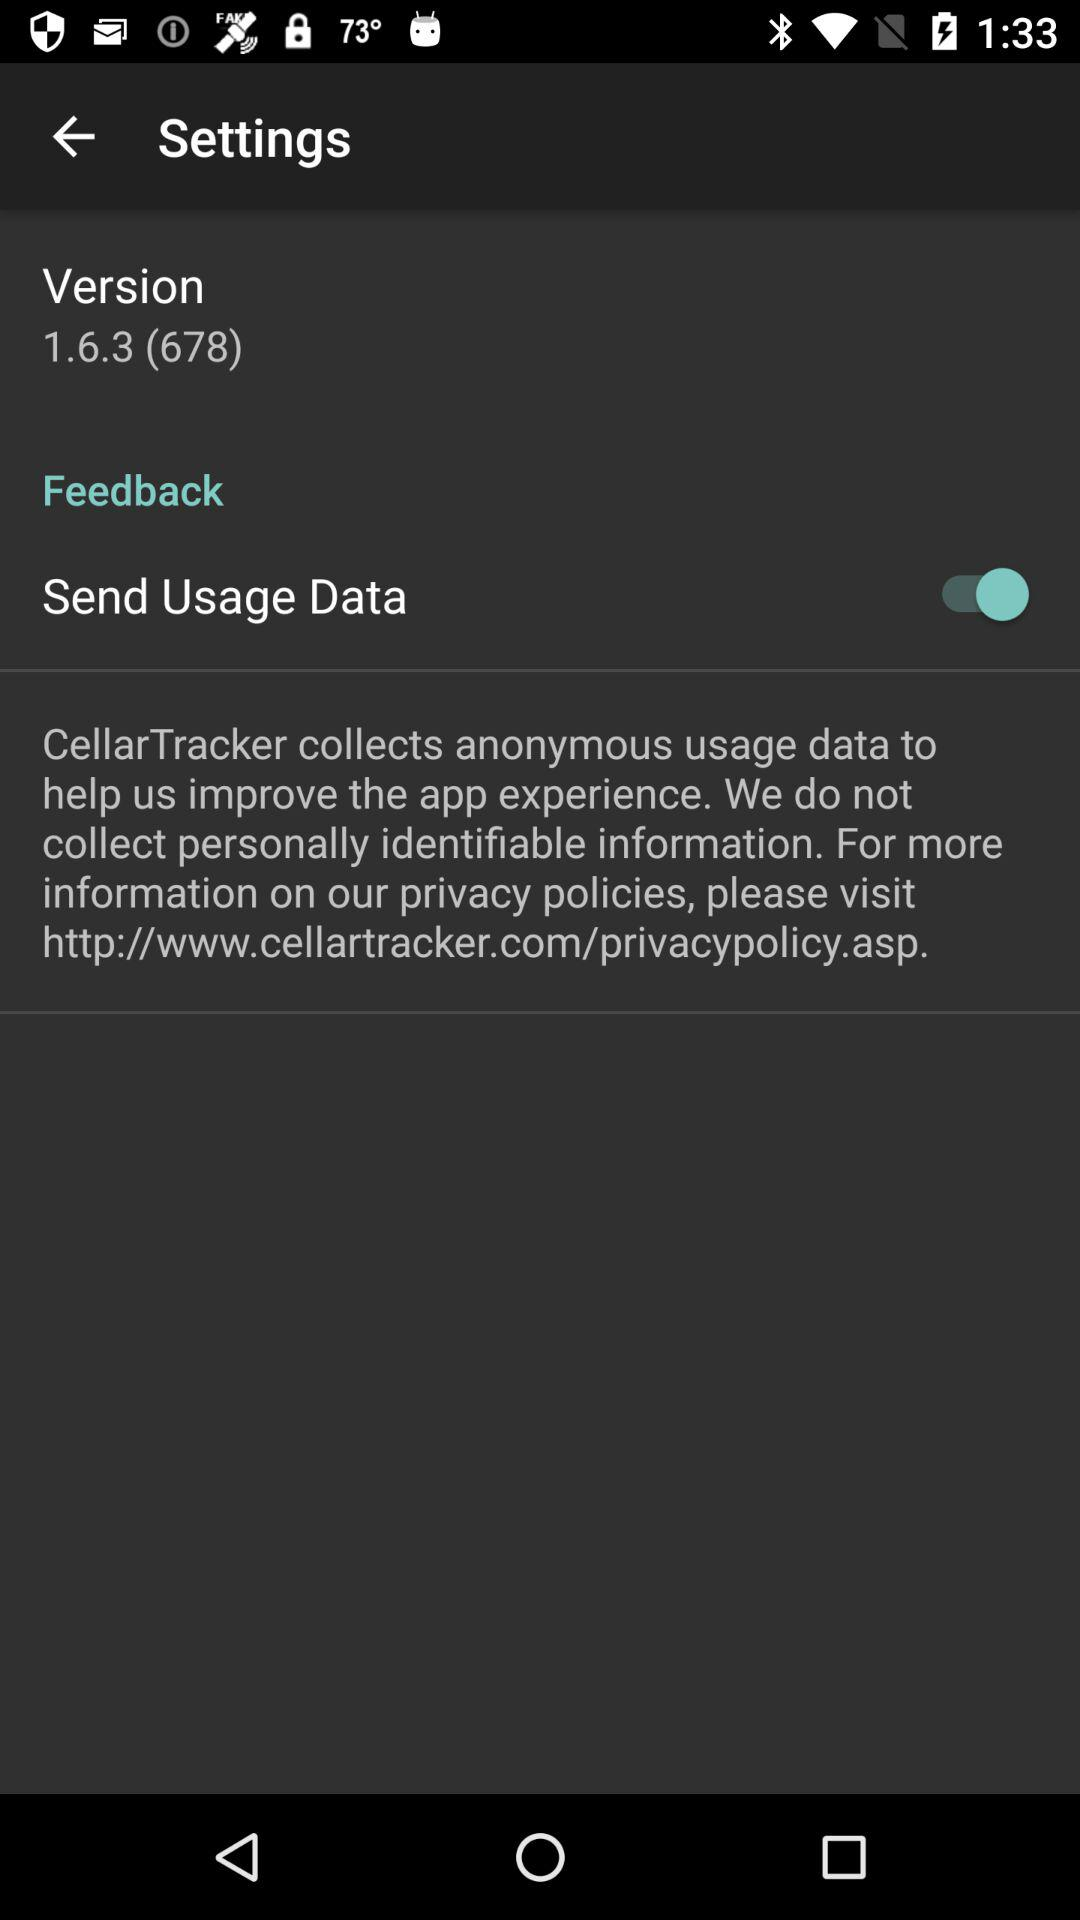What is the version? The version is 1.6.3 (678). 